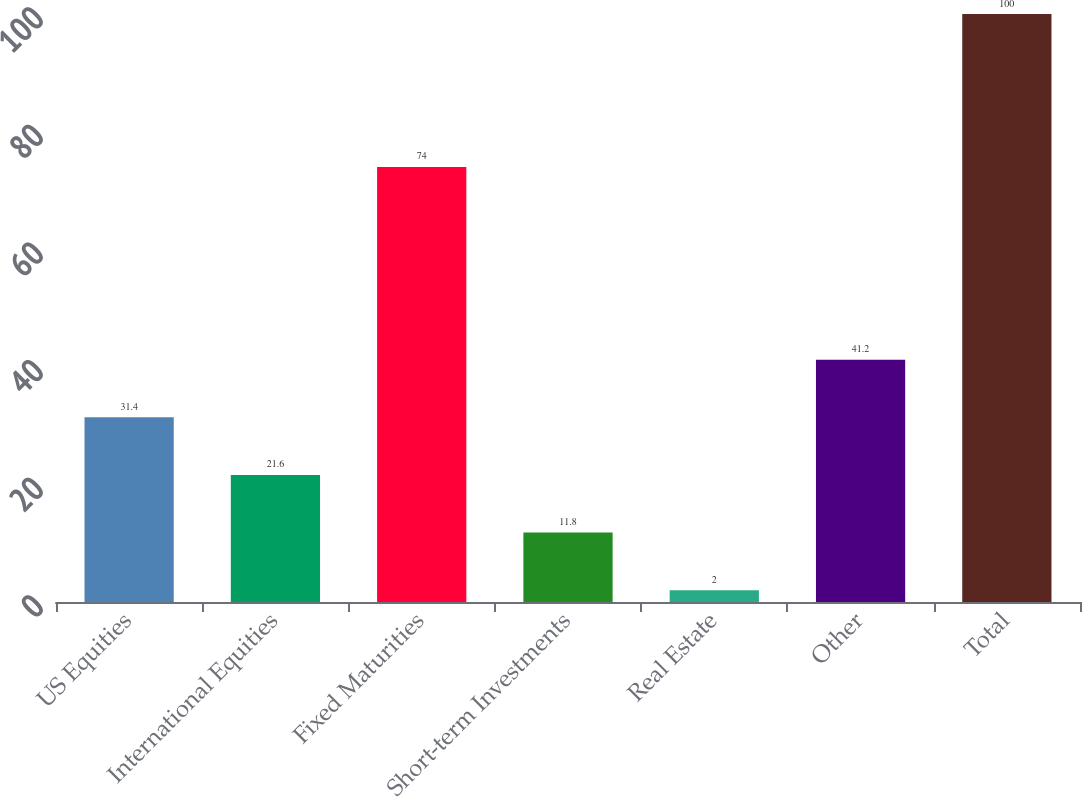Convert chart. <chart><loc_0><loc_0><loc_500><loc_500><bar_chart><fcel>US Equities<fcel>International Equities<fcel>Fixed Maturities<fcel>Short-term Investments<fcel>Real Estate<fcel>Other<fcel>Total<nl><fcel>31.4<fcel>21.6<fcel>74<fcel>11.8<fcel>2<fcel>41.2<fcel>100<nl></chart> 